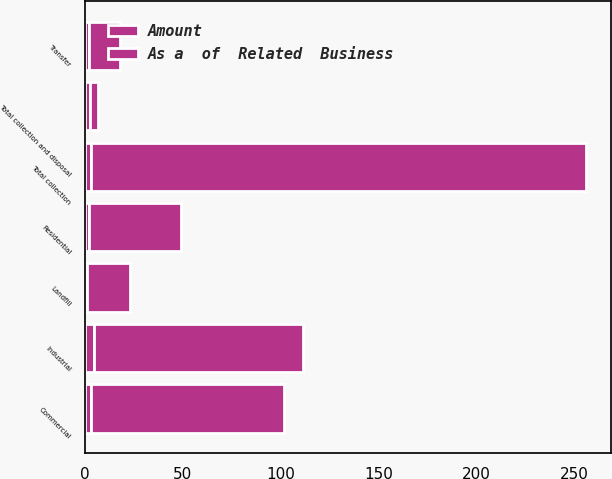Convert chart to OTSL. <chart><loc_0><loc_0><loc_500><loc_500><stacked_bar_chart><ecel><fcel>Commercial<fcel>Industrial<fcel>Residential<fcel>Total collection<fcel>Landfill<fcel>Transfer<fcel>Total collection and disposal<nl><fcel>As a  of  Related  Business<fcel>99<fcel>107<fcel>47<fcel>253<fcel>22<fcel>16<fcel>4.4<nl><fcel>Amount<fcel>2.9<fcel>4.4<fcel>1.9<fcel>2.9<fcel>1.1<fcel>1.9<fcel>2.3<nl></chart> 